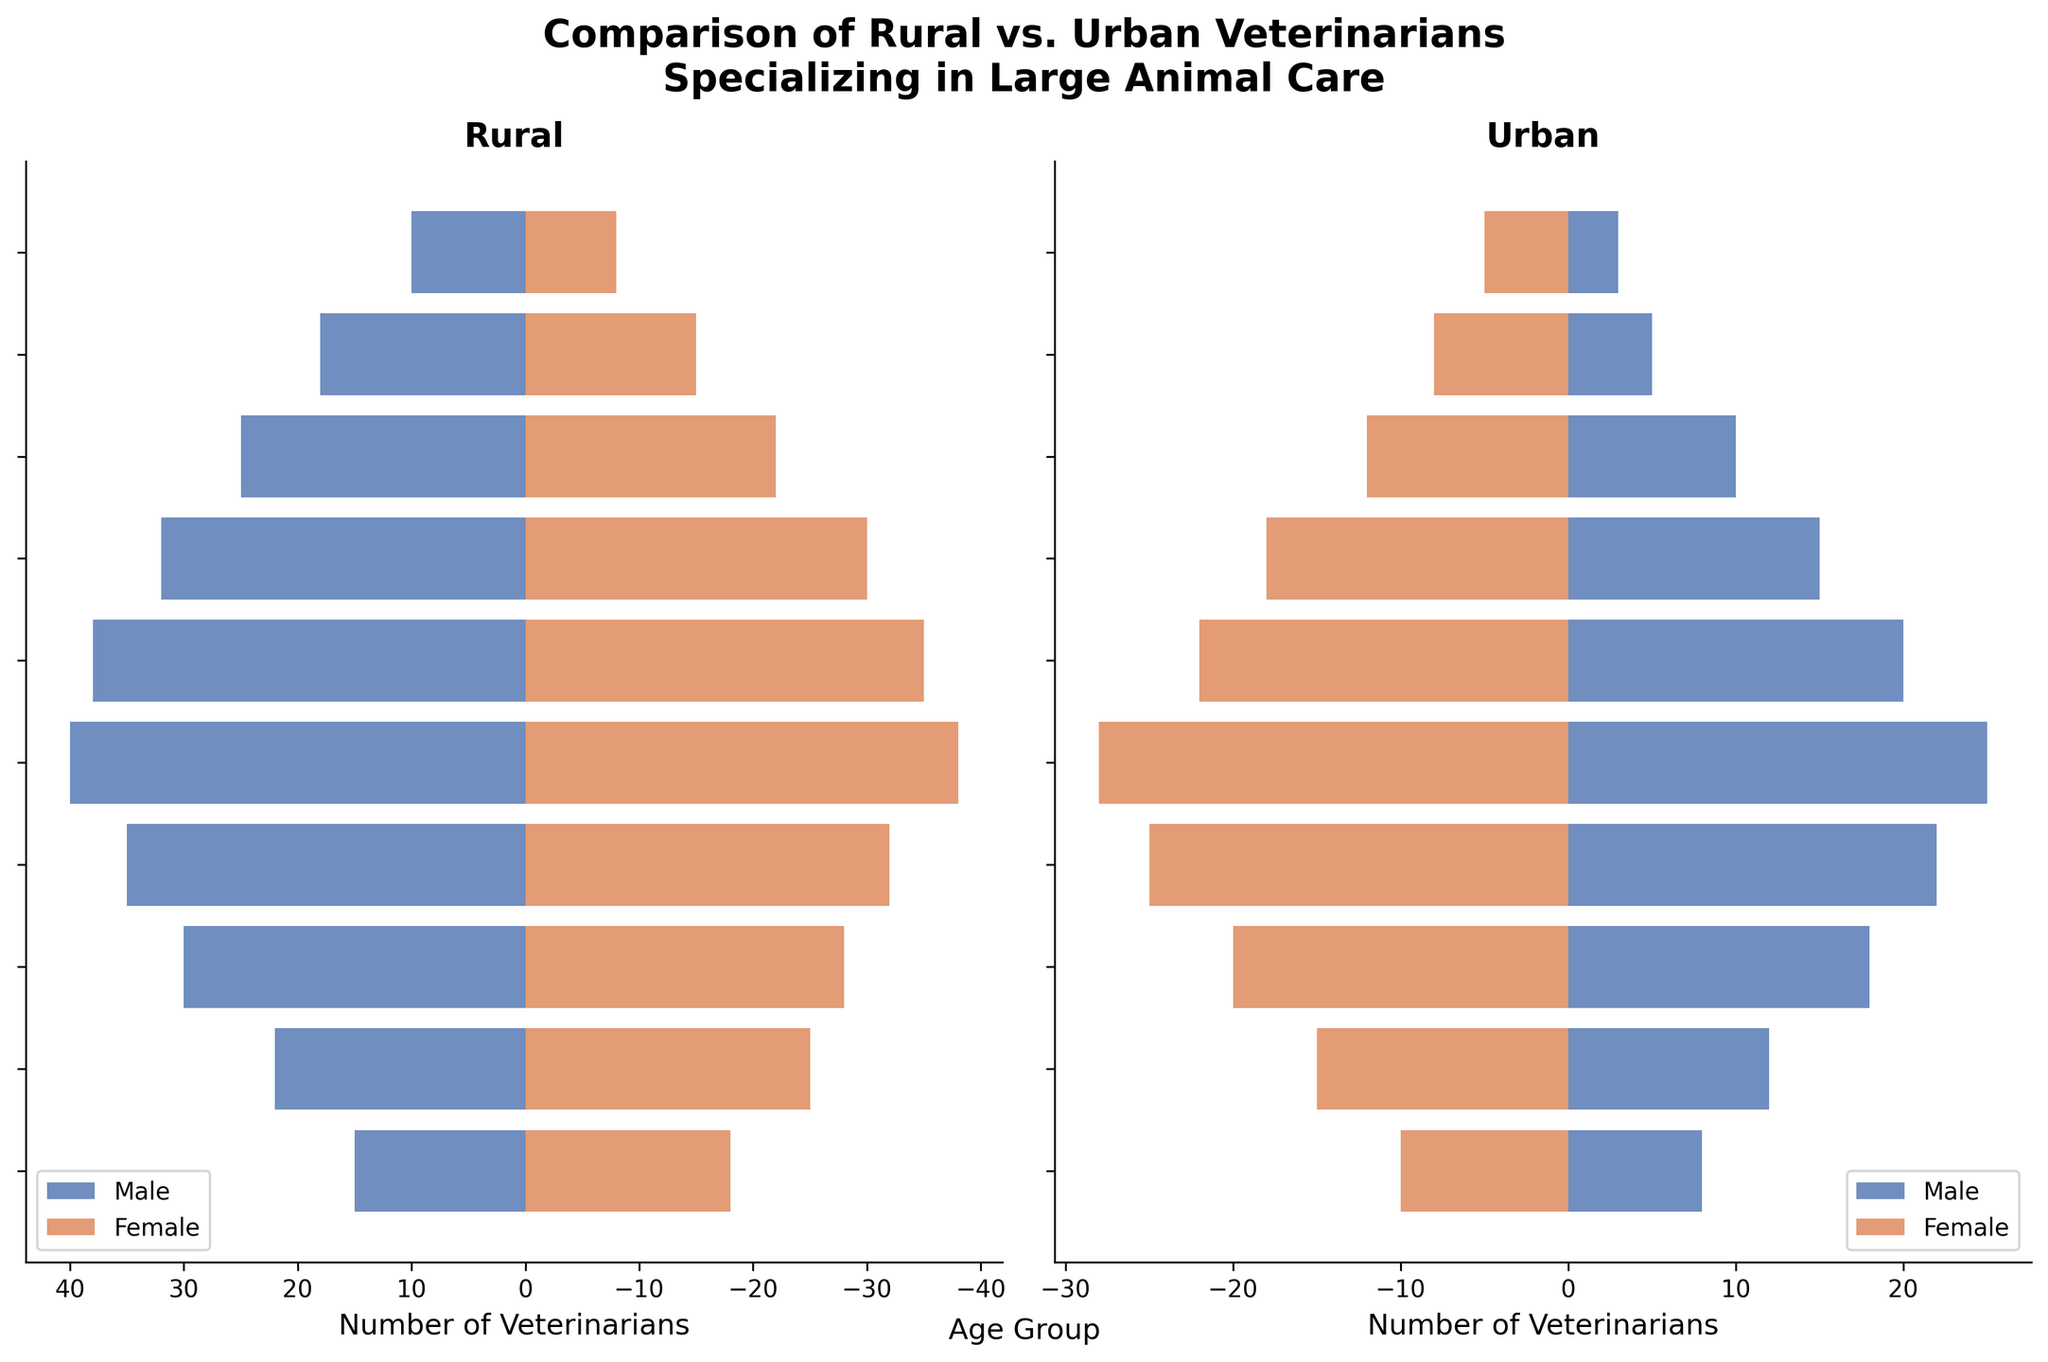What is the age group with the highest number of rural male veterinarians? From the plot, look at the bar lengths corresponding to "Rural Male". The longest bar is for the age group "40-44".
Answer: 40-44 Which age group has more urban female veterinarians than urban male veterinarians? Compare the length of the bars for "Urban Female" and "Urban Male" for each age group. "65+" is one such age group where urban females outnumber urban males.
Answer: 65+ What is the total number of rural veterinarians in the 30-34 age group? Add the number of rural males and rural females in the 30-34 age group: 30 (males) + 28 (females) = 58
Answer: 58 Which gender has more veterinarians in rural areas in the 50-54 age group? Compare the bar lengths for "Rural Male" and "Rural Female" in the 50-54 age group. The "Rural Male" bar is longer.
Answer: Male How does the number of urban veterinarians in the 25-29 age group compare between males and females? Look at the bars for "Urban Male" and "Urban Female" in the 25-29 age group. There are 15 urban females and 12 urban males, so females outnumber males.
Answer: Females outnumber males In which age group do rural female veterinarians exceed 30 individuals? Check if the bar for "Rural Female" exceeds 30 for each age group. It does not exceed 30 in any age group.
Answer: None How does the number of rural male veterinarians in the 35-39 age group compare to the number of urban male veterinarians in the same age group? Compare the bar lengths for "Rural Male" (35) and "Urban Male" (22) in the 35-39 age group. Rural males outnumber urban males.
Answer: Rural males outnumber urban males What is the difference in the number of rural male and rural female veterinarians in the 40-44 age group? Subtract the number of rural females from rural males in the 40-44 age group: 40 (males) - 38 (females) = 2
Answer: 2 Which urban age group has the least number of veterinarians regardless of gender? Look for the smallest bars in the "Urban" plot. The 60-64 age group has the least total number of urban veterinarians (5 males + 8 females = 13).
Answer: 60-64 How do the total numbers of veterinarians in the 20-24 age group compare between rural and urban areas? Add the number of males and females in the 20-24 age group for both rural and urban areas: Rural: 15 (males) + 18 (females) = 33; Urban: 8 (males) + 10 (females) = 18. Rural areas have more.
Answer: Rural areas have more 